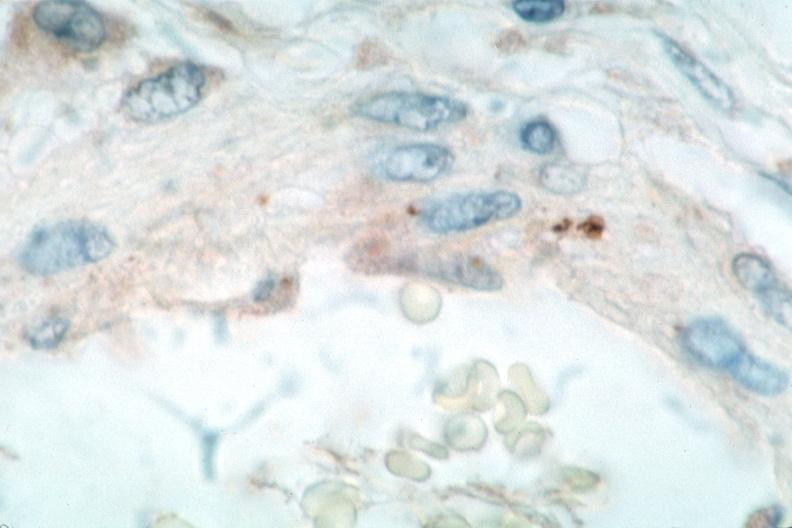s rocky mountain spotted fever, immunoperoxidase staining vessels for rickettsia rickettsii?
Answer the question using a single word or phrase. Yes 